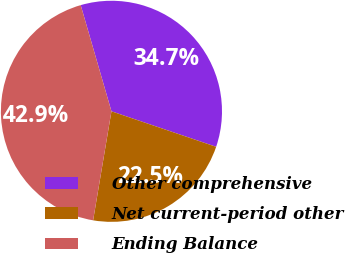Convert chart to OTSL. <chart><loc_0><loc_0><loc_500><loc_500><pie_chart><fcel>Other comprehensive<fcel>Net current-period other<fcel>Ending Balance<nl><fcel>34.69%<fcel>22.45%<fcel>42.86%<nl></chart> 